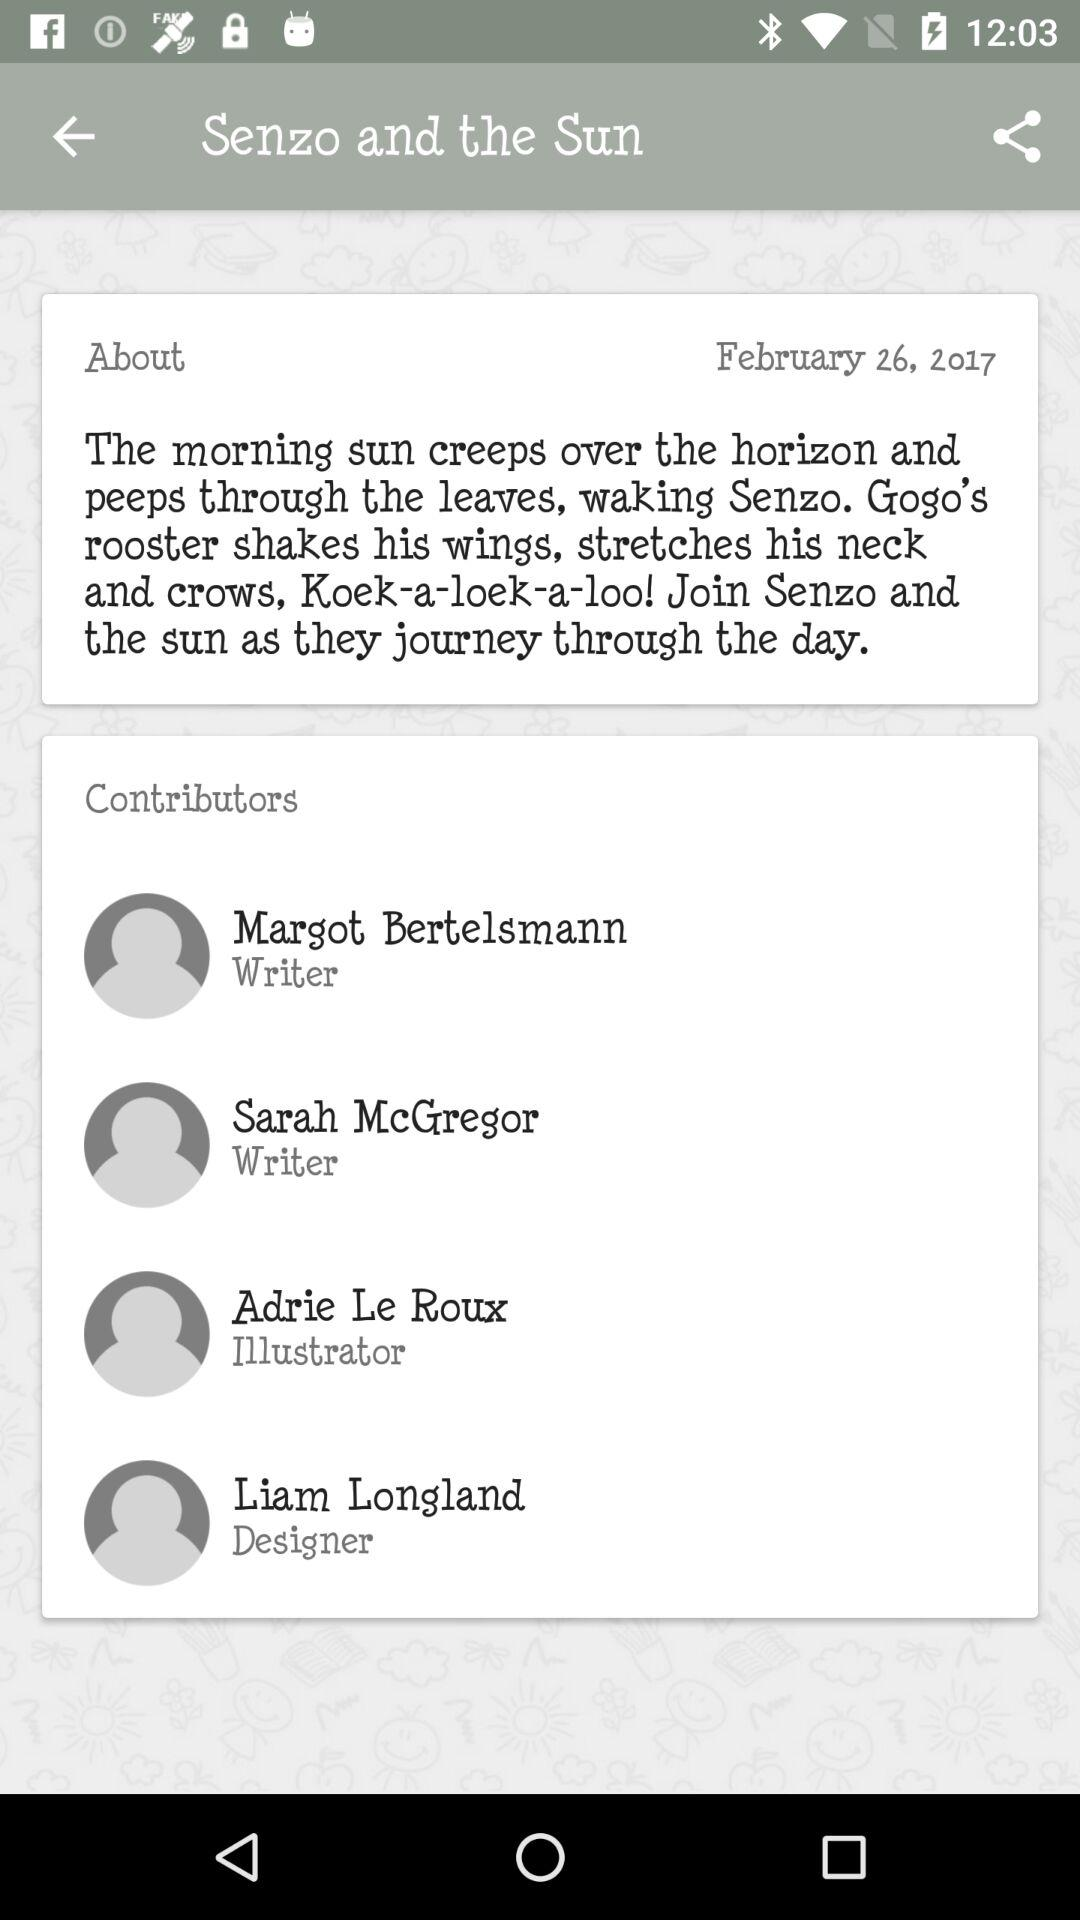What is the date? The date is February 26, 2017. 